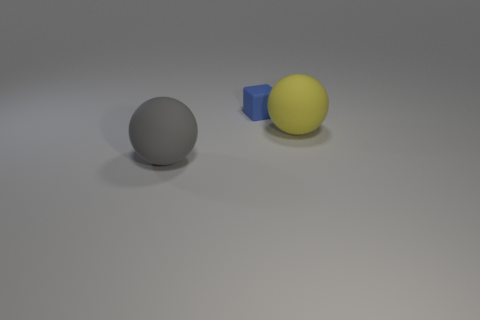Add 2 tiny blue cubes. How many objects exist? 5 Subtract all balls. How many objects are left? 1 Subtract all big gray things. Subtract all small blue matte blocks. How many objects are left? 1 Add 2 blue cubes. How many blue cubes are left? 3 Add 2 tiny blocks. How many tiny blocks exist? 3 Subtract 0 blue balls. How many objects are left? 3 